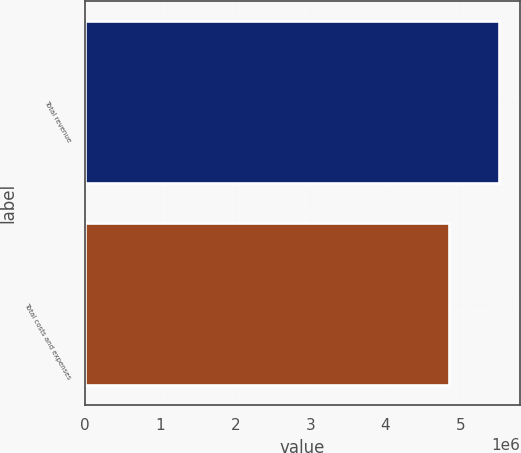Convert chart. <chart><loc_0><loc_0><loc_500><loc_500><bar_chart><fcel>Total revenue<fcel>Total costs and expenses<nl><fcel>5.51818e+06<fcel>4.85254e+06<nl></chart> 